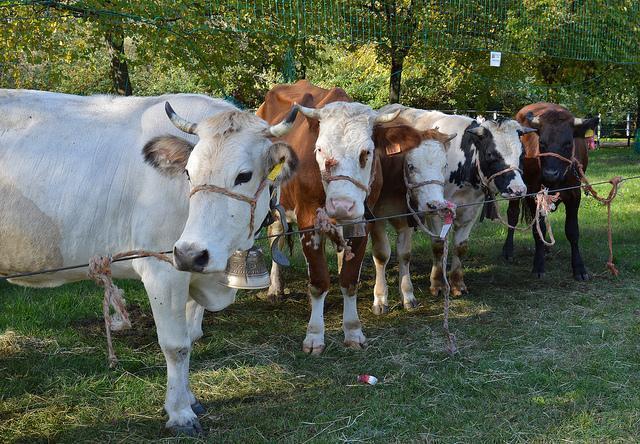What is the most common breed of milk cow?
Select the accurate answer and provide explanation: 'Answer: answer
Rationale: rationale.'
Options: Brown swiss, holstein, ayrshire, jersey. Answer: holstein.
Rationale: The holstein cow is the most common cow used at a dairy farm 